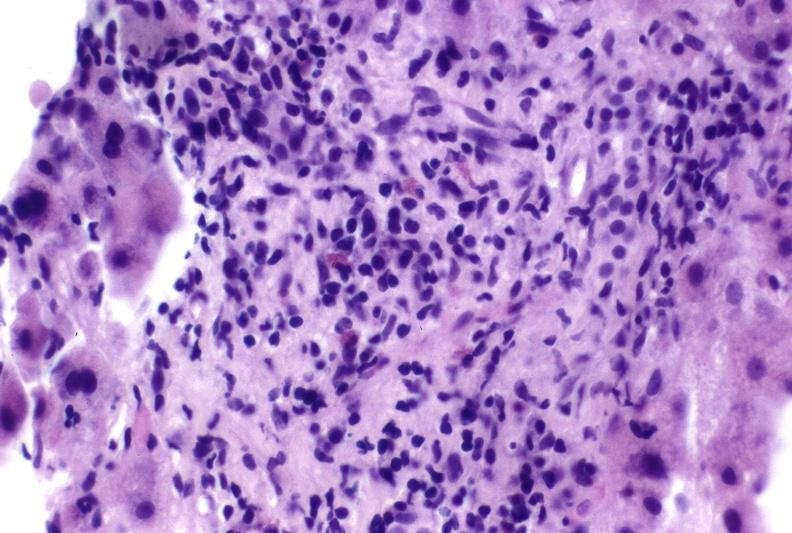s liver present?
Answer the question using a single word or phrase. Yes 